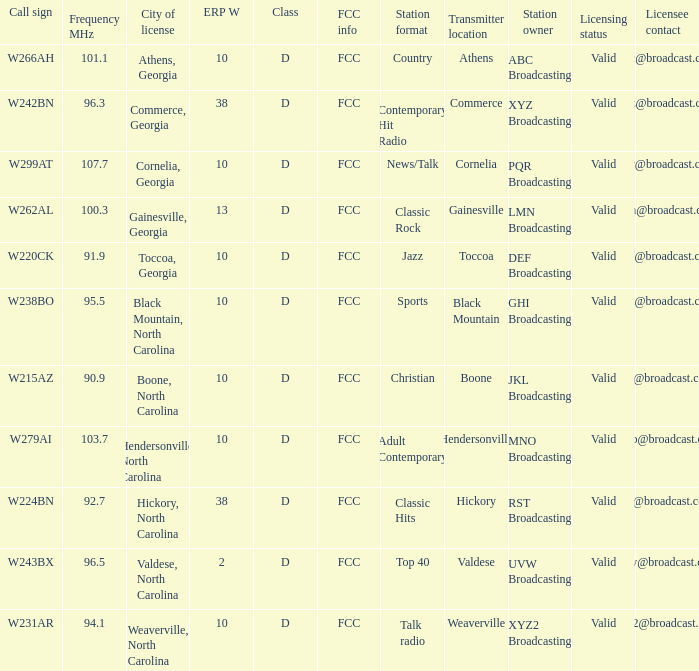What class is the city of black mountain, north carolina? D. 